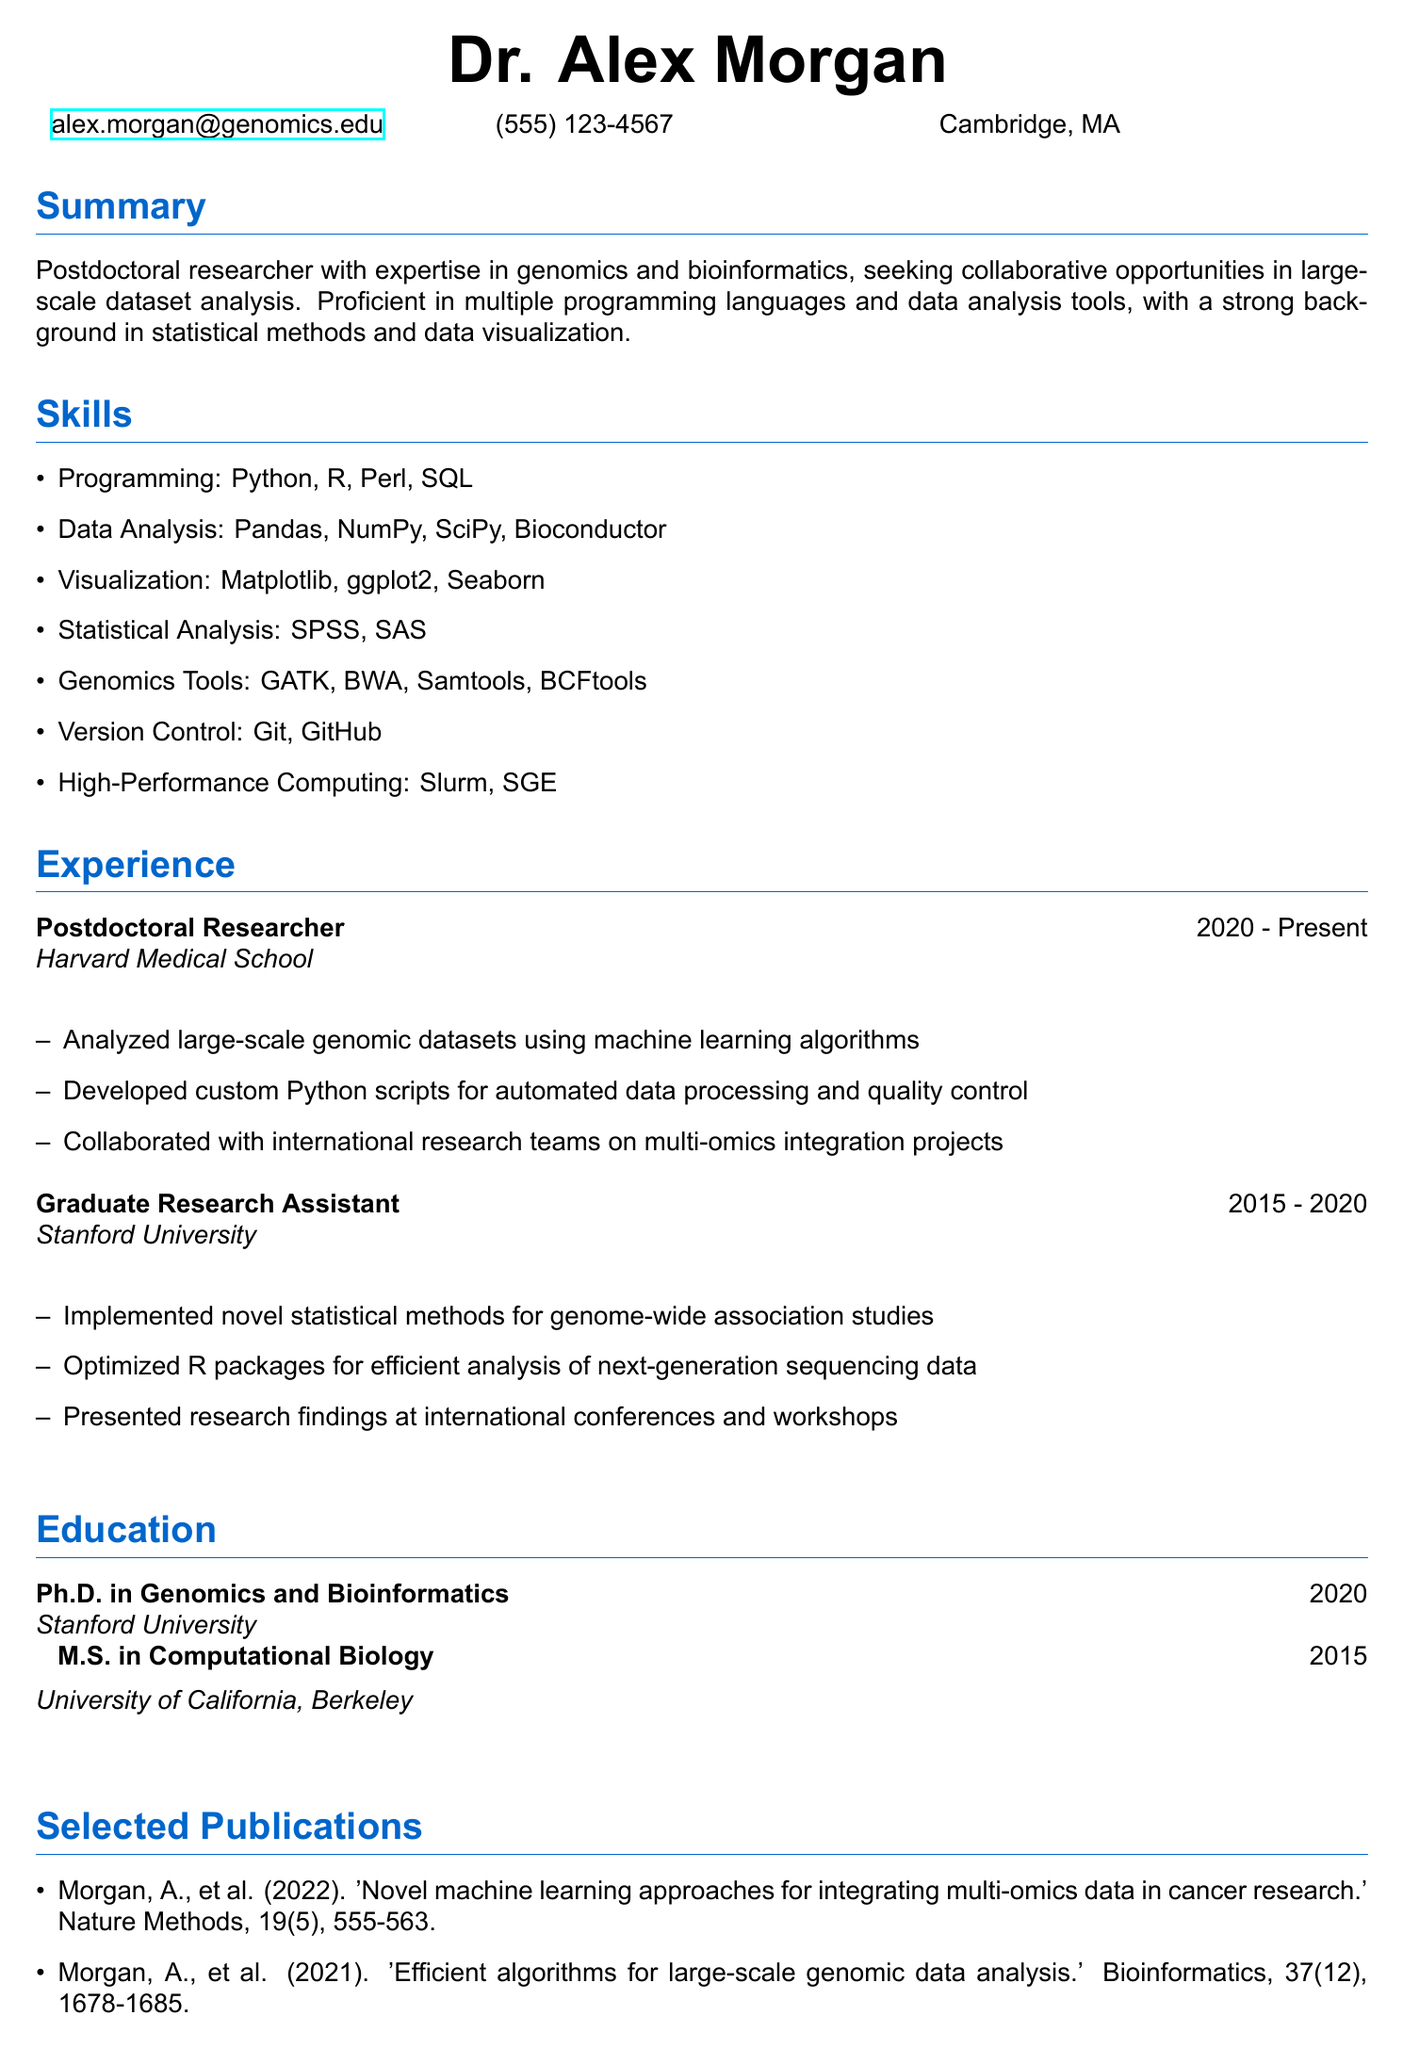What is the name of the researcher? The researcher's name is provided at the top of the document.
Answer: Dr. Alex Morgan What is the primary area of expertise? The summary states the researcher's main area of focus.
Answer: Genomics and bioinformatics Which programming languages is the researcher proficient in? The skills section lists the programming languages the researcher is skilled in.
Answer: Python, R, Perl, SQL What is the title of the current position held? The experience section lists the current professional title of the researcher.
Answer: Postdoctoral Researcher How many years did the researcher spend at Stanford University? The timeline in the experience section outlines the duration of the researcher's role at Stanford.
Answer: 5 years What was a specific responsibility at Harvard Medical School? The responsibilities listed for the current position highlight key tasks.
Answer: Analyzed large-scale genomic datasets using machine learning algorithms Which statistical analysis software is mentioned? The skills section enumerates the statistical software the researcher is familiar with.
Answer: SPSS, SAS What is the highest degree obtained by the researcher? The education section indicates the highest level of education achieved.
Answer: Ph.D. in Genomics and Bioinformatics Name one publication by the researcher. The selected publications section provides titles of the researcher's work.
Answer: 'Novel machine learning approaches for integrating multi-omics data in cancer research' 